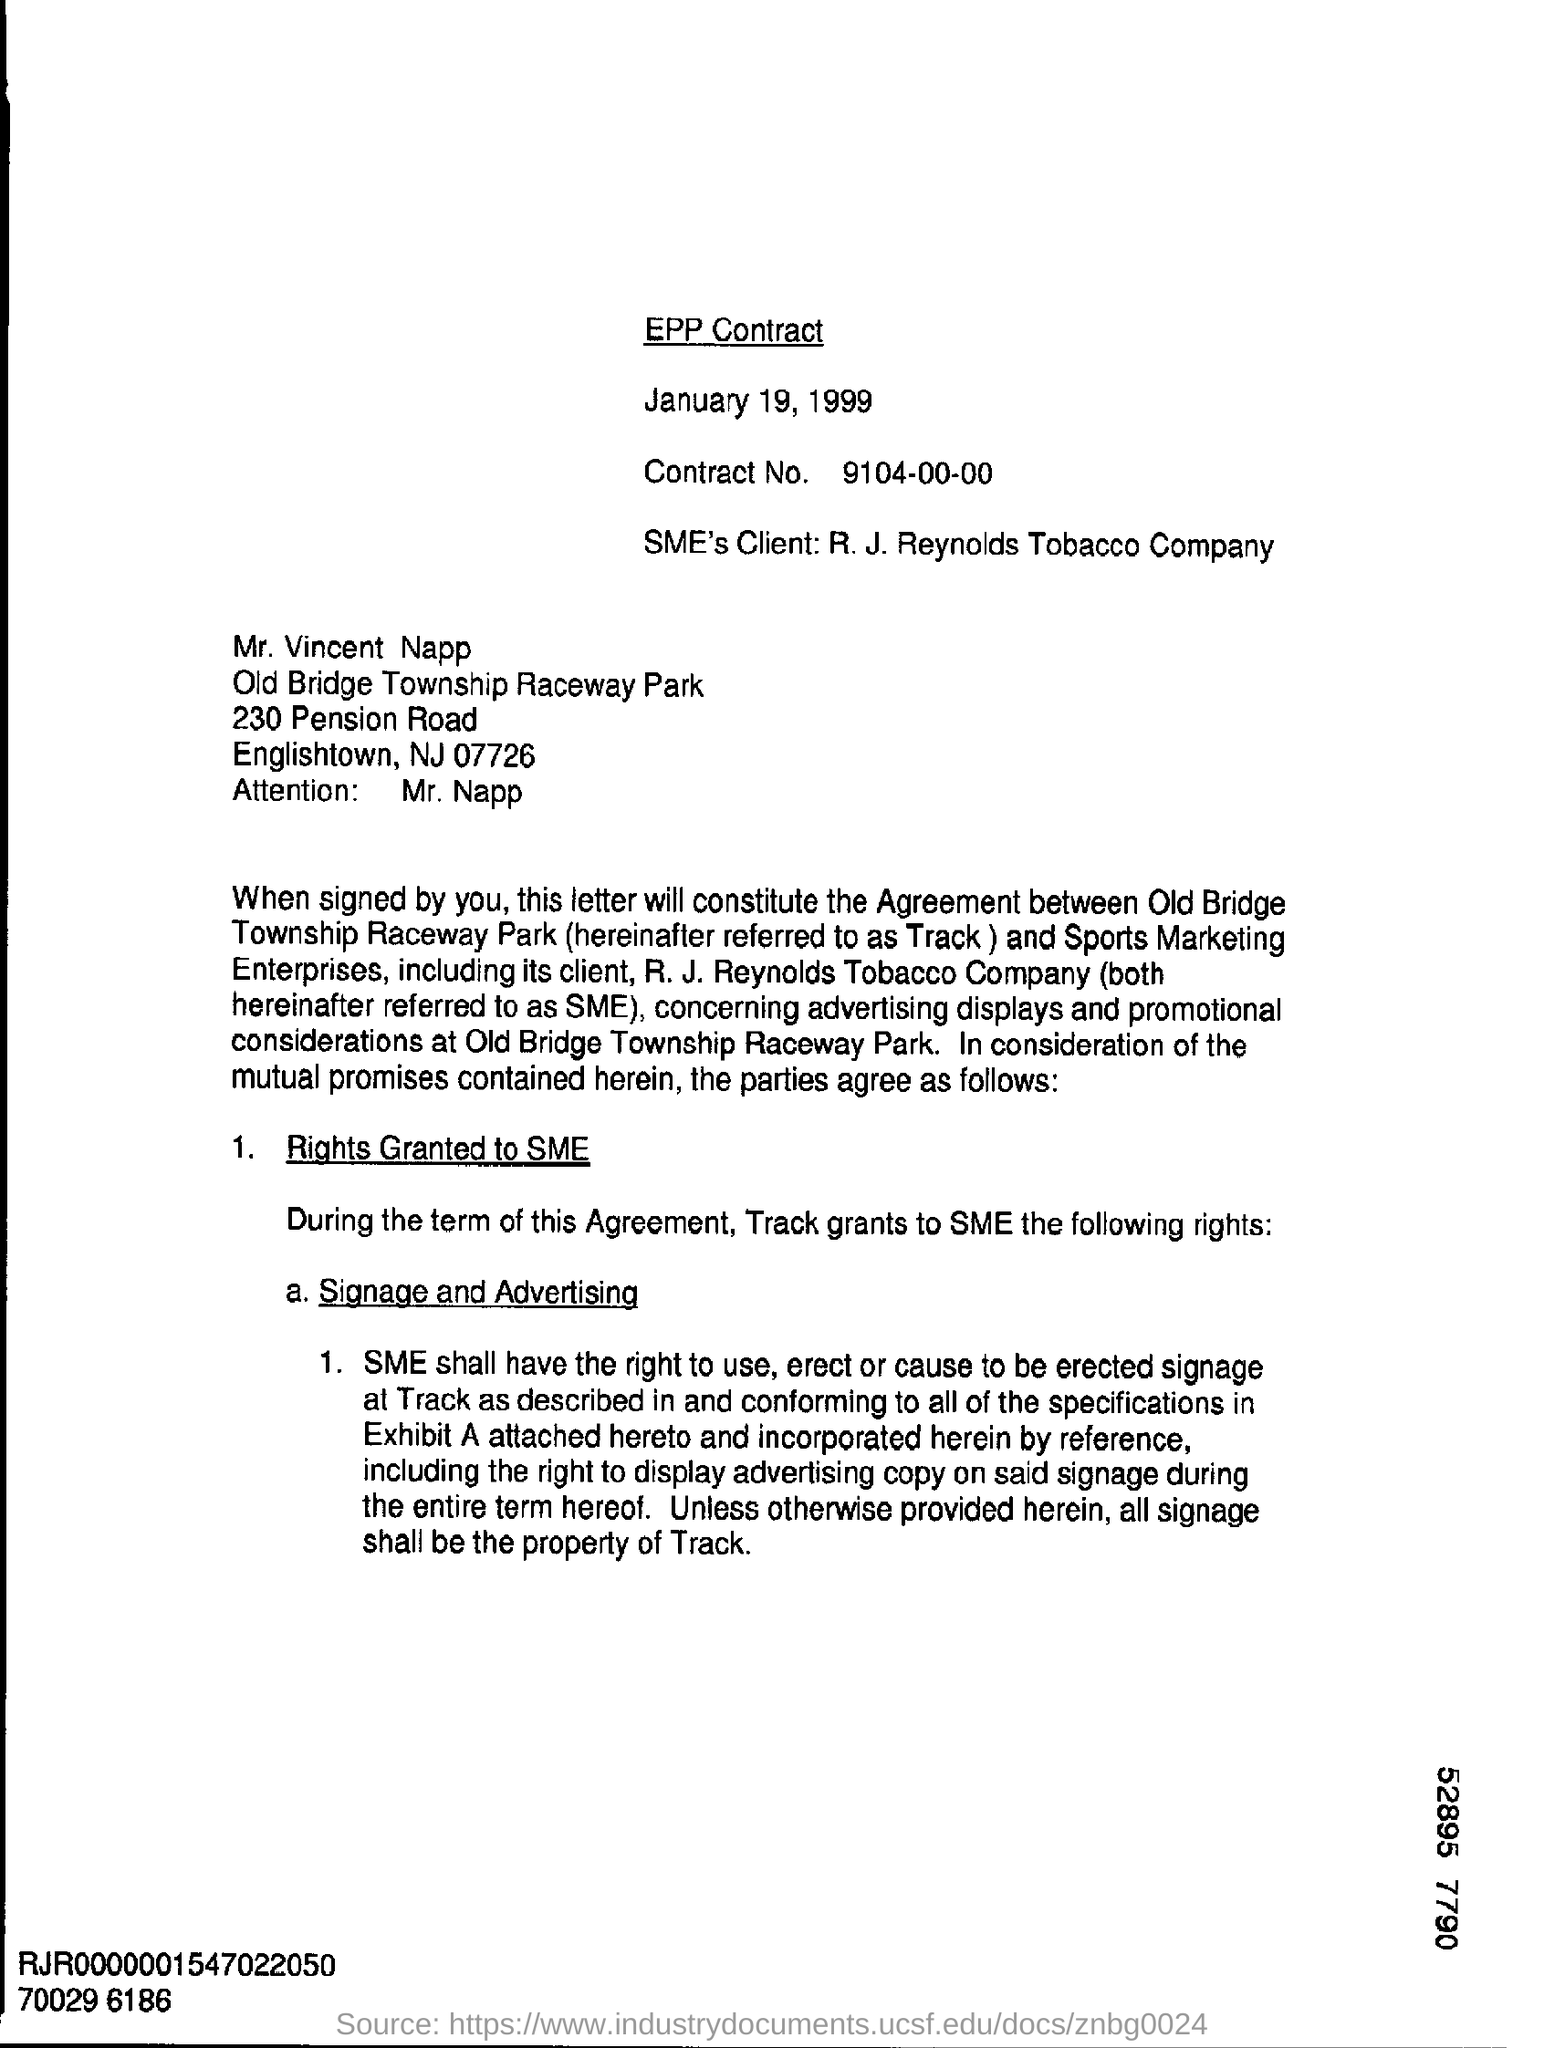Could you tell me what the main purpose of this contract is? The main purpose of the contract depicted in the image is to formalize an agreement between Old Bridge Township Raceway Park and Sports Marketing Enterprises, including its client R. J. Reynolds Tobacco Company. It concerns advertising displays and promotional considerations at the raceway park. 